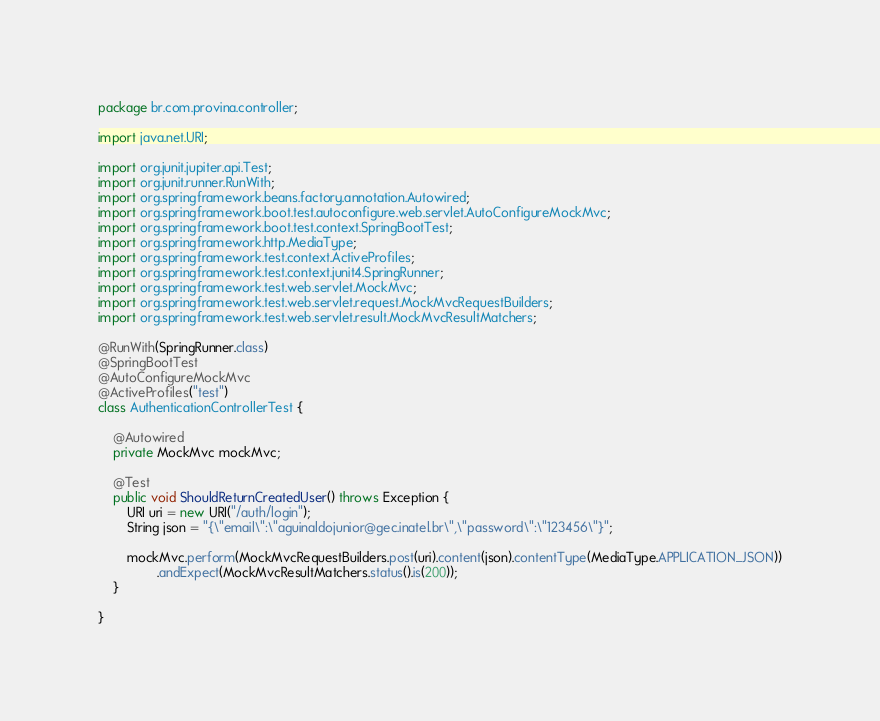<code> <loc_0><loc_0><loc_500><loc_500><_Java_>package br.com.provina.controller;

import java.net.URI;

import org.junit.jupiter.api.Test;
import org.junit.runner.RunWith;
import org.springframework.beans.factory.annotation.Autowired;
import org.springframework.boot.test.autoconfigure.web.servlet.AutoConfigureMockMvc;
import org.springframework.boot.test.context.SpringBootTest;
import org.springframework.http.MediaType;
import org.springframework.test.context.ActiveProfiles;
import org.springframework.test.context.junit4.SpringRunner;
import org.springframework.test.web.servlet.MockMvc;
import org.springframework.test.web.servlet.request.MockMvcRequestBuilders;
import org.springframework.test.web.servlet.result.MockMvcResultMatchers;

@RunWith(SpringRunner.class)
@SpringBootTest
@AutoConfigureMockMvc
@ActiveProfiles("test")
class AuthenticationControllerTest {

	@Autowired
	private MockMvc mockMvc;

	@Test
	public void ShouldReturnCreatedUser() throws Exception {
		URI uri = new URI("/auth/login");
		String json = "{\"email\":\"aguinaldojunior@gec.inatel.br\",\"password\":\"123456\"}";

		mockMvc.perform(MockMvcRequestBuilders.post(uri).content(json).contentType(MediaType.APPLICATION_JSON))
				.andExpect(MockMvcResultMatchers.status().is(200));
	}

}
</code> 